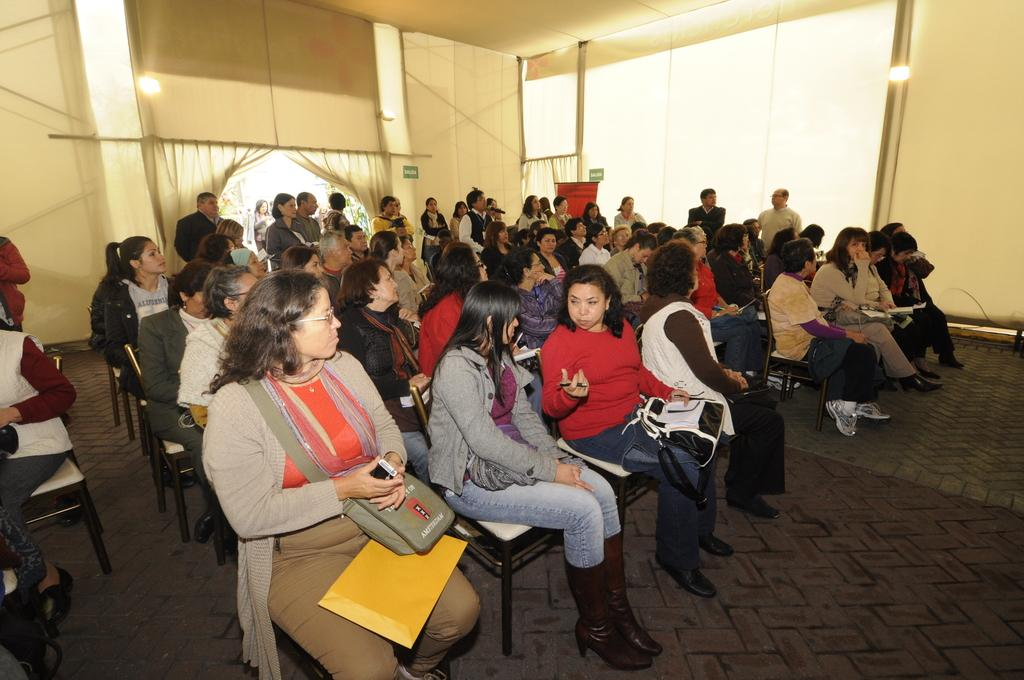What is the setting of the image? The image shows the inside of a hall. What are the people in the hall doing? There are many people sitting in chairs in the hall. How many exits are visible in the background? There are two exits visible in the background. What is happening with the people coming through the exits? Some people are coming through the exits. What type of bait is being used to attract visitors in the image? There is no mention of bait or visitors in the image; it shows people sitting in chairs in a hall with exits. 